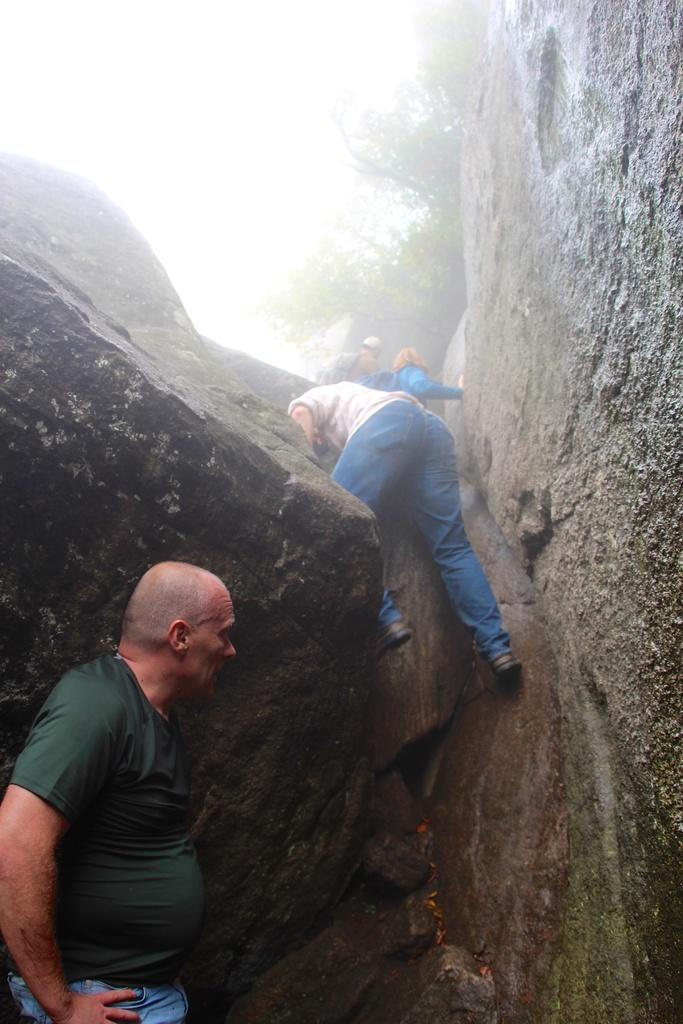What are the people in the image doing? There are persons climbing a wall in the center of the image. Can you describe the person in the front of the image? There is a person standing in the front of the image. What can be seen in the background of the image? There are trees in the background of the image. What type of surface are the climbers using? There are stones in the center of the image, which the climbers are using. How many tomatoes are on the drawer in the image? There are no tomatoes or drawers present in the image. What type of downtown area can be seen in the image? There is no downtown area depicted in the image; it features people climbing a wall with stones in the center and trees in the background. 